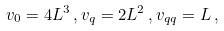<formula> <loc_0><loc_0><loc_500><loc_500>v _ { 0 } = 4 L ^ { 3 } \, , v _ { q } = 2 L ^ { 2 } \, , v _ { q q } = L \, ,</formula> 